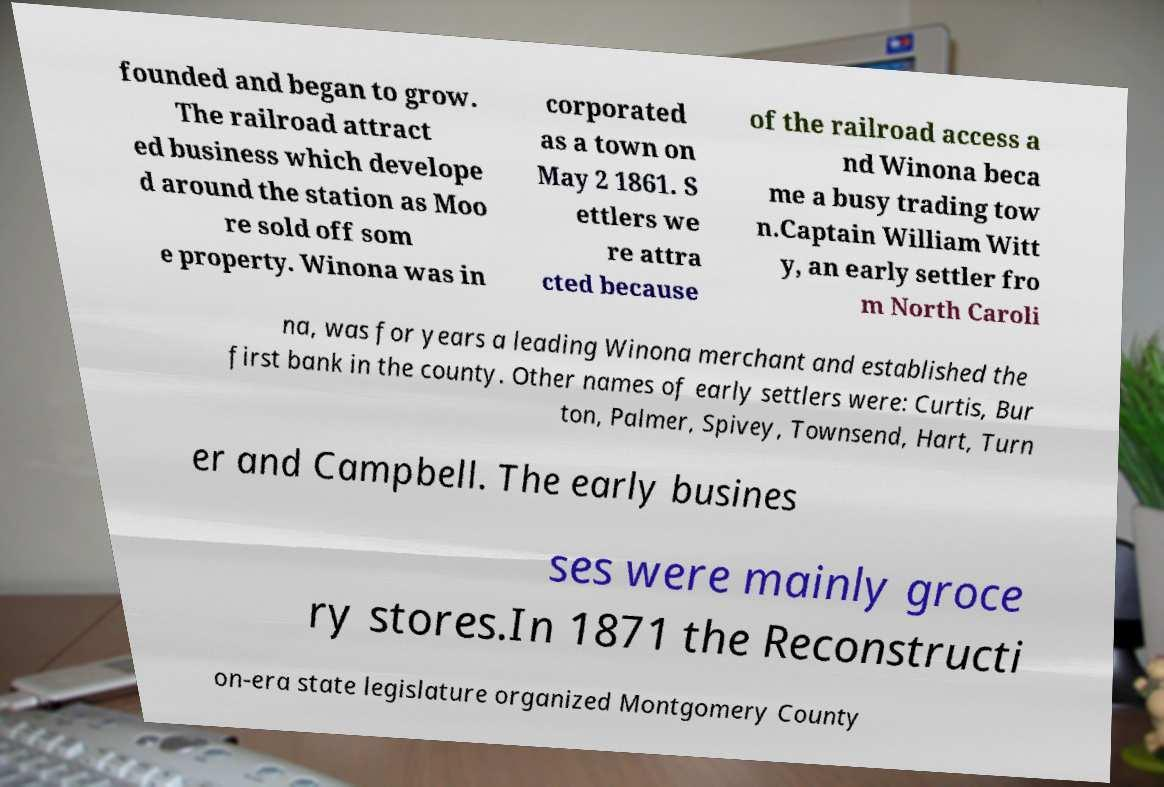For documentation purposes, I need the text within this image transcribed. Could you provide that? founded and began to grow. The railroad attract ed business which develope d around the station as Moo re sold off som e property. Winona was in corporated as a town on May 2 1861. S ettlers we re attra cted because of the railroad access a nd Winona beca me a busy trading tow n.Captain William Witt y, an early settler fro m North Caroli na, was for years a leading Winona merchant and established the first bank in the county. Other names of early settlers were: Curtis, Bur ton, Palmer, Spivey, Townsend, Hart, Turn er and Campbell. The early busines ses were mainly groce ry stores.In 1871 the Reconstructi on-era state legislature organized Montgomery County 